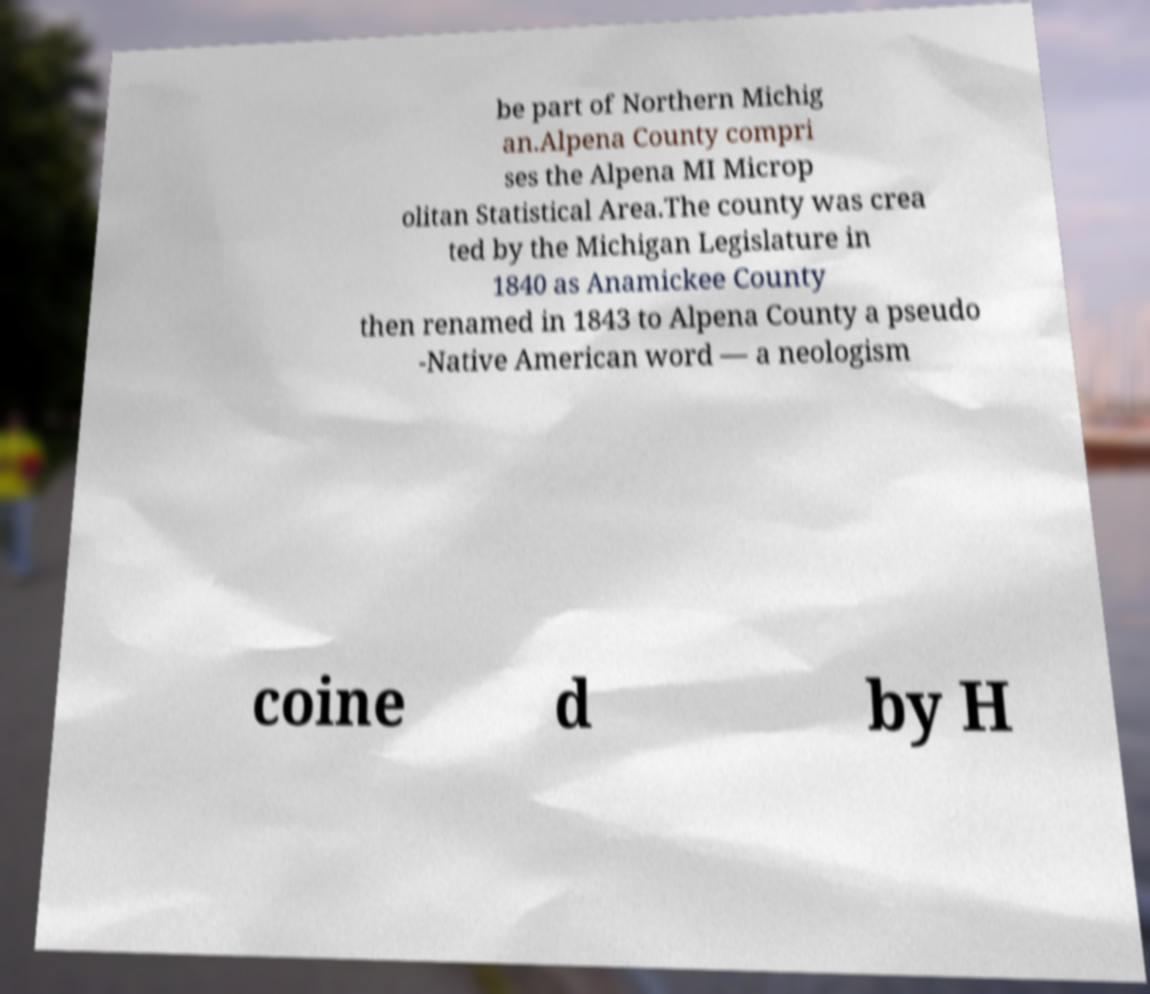What messages or text are displayed in this image? I need them in a readable, typed format. be part of Northern Michig an.Alpena County compri ses the Alpena MI Microp olitan Statistical Area.The county was crea ted by the Michigan Legislature in 1840 as Anamickee County then renamed in 1843 to Alpena County a pseudo -Native American word — a neologism coine d by H 